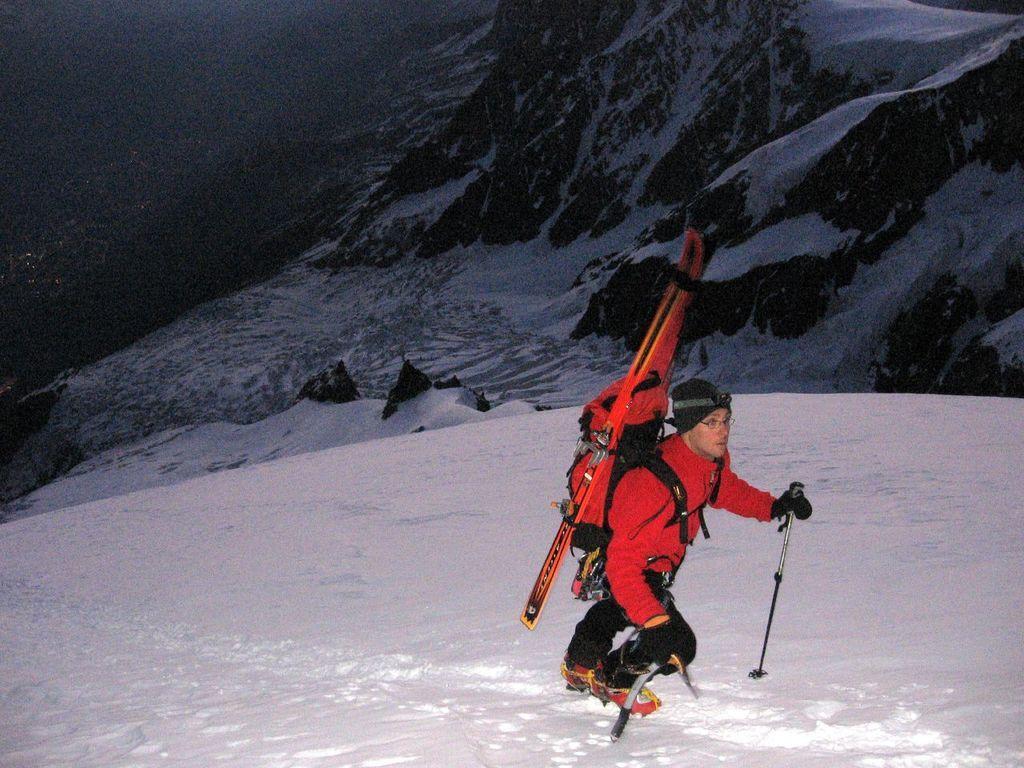In one or two sentences, can you explain what this image depicts? The picture is taken on the mountain where snow is covered and one man is wearing red shirt, black pant and shoes, holding sticks in his hands and carrying backpack and skaters on his shoulder. 